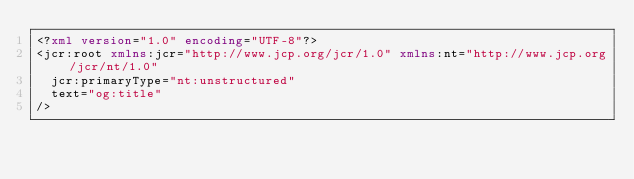Convert code to text. <code><loc_0><loc_0><loc_500><loc_500><_XML_><?xml version="1.0" encoding="UTF-8"?>
<jcr:root xmlns:jcr="http://www.jcp.org/jcr/1.0" xmlns:nt="http://www.jcp.org/jcr/nt/1.0"
  jcr:primaryType="nt:unstructured"
  text="og:title"
/>
</code> 